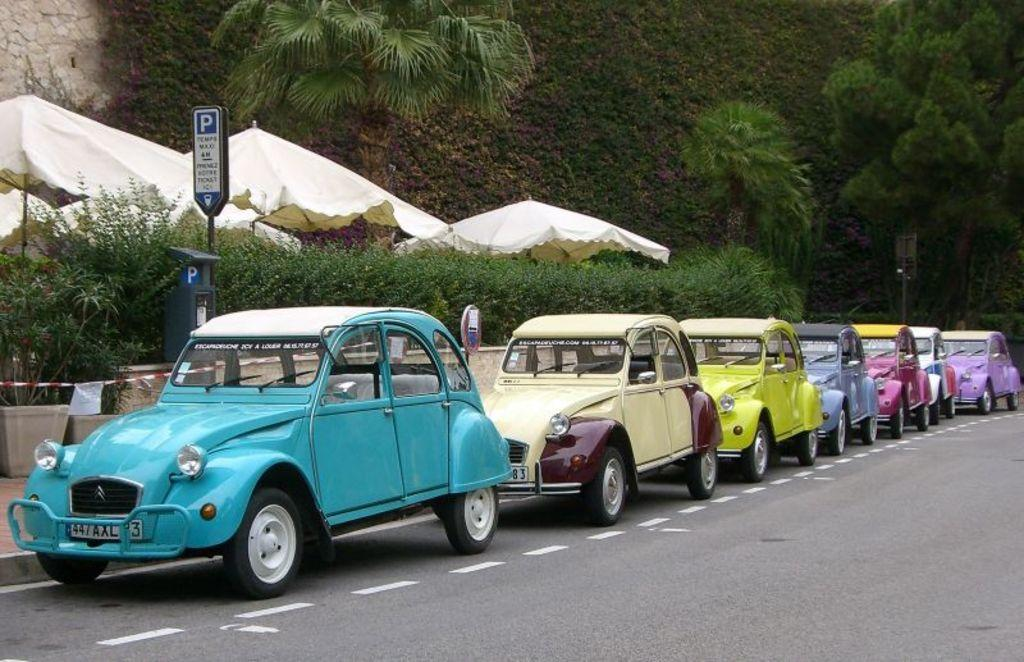What can be seen parked in the image? There are cars parked in the image. Where are the cars parked? The cars are parked on the side of a road. What can be seen in the background of the image? There are trees visible in the background of the image. What type of rod is the father using to catch fish in the image? There is no father or fishing rod present in the image; it only shows parked cars and trees in the background. 